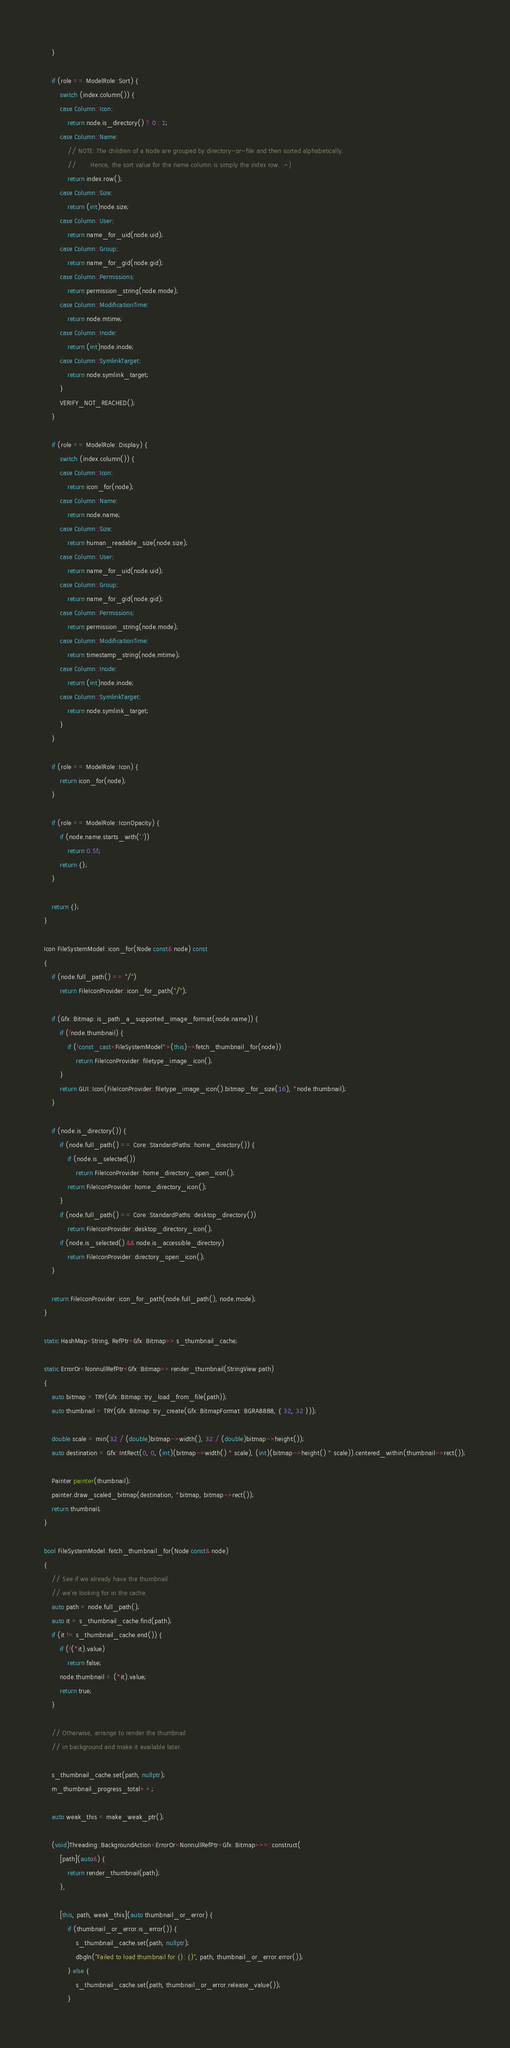Convert code to text. <code><loc_0><loc_0><loc_500><loc_500><_C++_>    }

    if (role == ModelRole::Sort) {
        switch (index.column()) {
        case Column::Icon:
            return node.is_directory() ? 0 : 1;
        case Column::Name:
            // NOTE: The children of a Node are grouped by directory-or-file and then sorted alphabetically.
            //       Hence, the sort value for the name column is simply the index row. :^)
            return index.row();
        case Column::Size:
            return (int)node.size;
        case Column::User:
            return name_for_uid(node.uid);
        case Column::Group:
            return name_for_gid(node.gid);
        case Column::Permissions:
            return permission_string(node.mode);
        case Column::ModificationTime:
            return node.mtime;
        case Column::Inode:
            return (int)node.inode;
        case Column::SymlinkTarget:
            return node.symlink_target;
        }
        VERIFY_NOT_REACHED();
    }

    if (role == ModelRole::Display) {
        switch (index.column()) {
        case Column::Icon:
            return icon_for(node);
        case Column::Name:
            return node.name;
        case Column::Size:
            return human_readable_size(node.size);
        case Column::User:
            return name_for_uid(node.uid);
        case Column::Group:
            return name_for_gid(node.gid);
        case Column::Permissions:
            return permission_string(node.mode);
        case Column::ModificationTime:
            return timestamp_string(node.mtime);
        case Column::Inode:
            return (int)node.inode;
        case Column::SymlinkTarget:
            return node.symlink_target;
        }
    }

    if (role == ModelRole::Icon) {
        return icon_for(node);
    }

    if (role == ModelRole::IconOpacity) {
        if (node.name.starts_with('.'))
            return 0.5f;
        return {};
    }

    return {};
}

Icon FileSystemModel::icon_for(Node const& node) const
{
    if (node.full_path() == "/")
        return FileIconProvider::icon_for_path("/");

    if (Gfx::Bitmap::is_path_a_supported_image_format(node.name)) {
        if (!node.thumbnail) {
            if (!const_cast<FileSystemModel*>(this)->fetch_thumbnail_for(node))
                return FileIconProvider::filetype_image_icon();
        }
        return GUI::Icon(FileIconProvider::filetype_image_icon().bitmap_for_size(16), *node.thumbnail);
    }

    if (node.is_directory()) {
        if (node.full_path() == Core::StandardPaths::home_directory()) {
            if (node.is_selected())
                return FileIconProvider::home_directory_open_icon();
            return FileIconProvider::home_directory_icon();
        }
        if (node.full_path() == Core::StandardPaths::desktop_directory())
            return FileIconProvider::desktop_directory_icon();
        if (node.is_selected() && node.is_accessible_directory)
            return FileIconProvider::directory_open_icon();
    }

    return FileIconProvider::icon_for_path(node.full_path(), node.mode);
}

static HashMap<String, RefPtr<Gfx::Bitmap>> s_thumbnail_cache;

static ErrorOr<NonnullRefPtr<Gfx::Bitmap>> render_thumbnail(StringView path)
{
    auto bitmap = TRY(Gfx::Bitmap::try_load_from_file(path));
    auto thumbnail = TRY(Gfx::Bitmap::try_create(Gfx::BitmapFormat::BGRA8888, { 32, 32 }));

    double scale = min(32 / (double)bitmap->width(), 32 / (double)bitmap->height());
    auto destination = Gfx::IntRect(0, 0, (int)(bitmap->width() * scale), (int)(bitmap->height() * scale)).centered_within(thumbnail->rect());

    Painter painter(thumbnail);
    painter.draw_scaled_bitmap(destination, *bitmap, bitmap->rect());
    return thumbnail;
}

bool FileSystemModel::fetch_thumbnail_for(Node const& node)
{
    // See if we already have the thumbnail
    // we're looking for in the cache.
    auto path = node.full_path();
    auto it = s_thumbnail_cache.find(path);
    if (it != s_thumbnail_cache.end()) {
        if (!(*it).value)
            return false;
        node.thumbnail = (*it).value;
        return true;
    }

    // Otherwise, arrange to render the thumbnail
    // in background and make it available later.

    s_thumbnail_cache.set(path, nullptr);
    m_thumbnail_progress_total++;

    auto weak_this = make_weak_ptr();

    (void)Threading::BackgroundAction<ErrorOr<NonnullRefPtr<Gfx::Bitmap>>>::construct(
        [path](auto&) {
            return render_thumbnail(path);
        },

        [this, path, weak_this](auto thumbnail_or_error) {
            if (thumbnail_or_error.is_error()) {
                s_thumbnail_cache.set(path, nullptr);
                dbgln("Failed to load thumbnail for {}: {}", path, thumbnail_or_error.error());
            } else {
                s_thumbnail_cache.set(path, thumbnail_or_error.release_value());
            }
</code> 